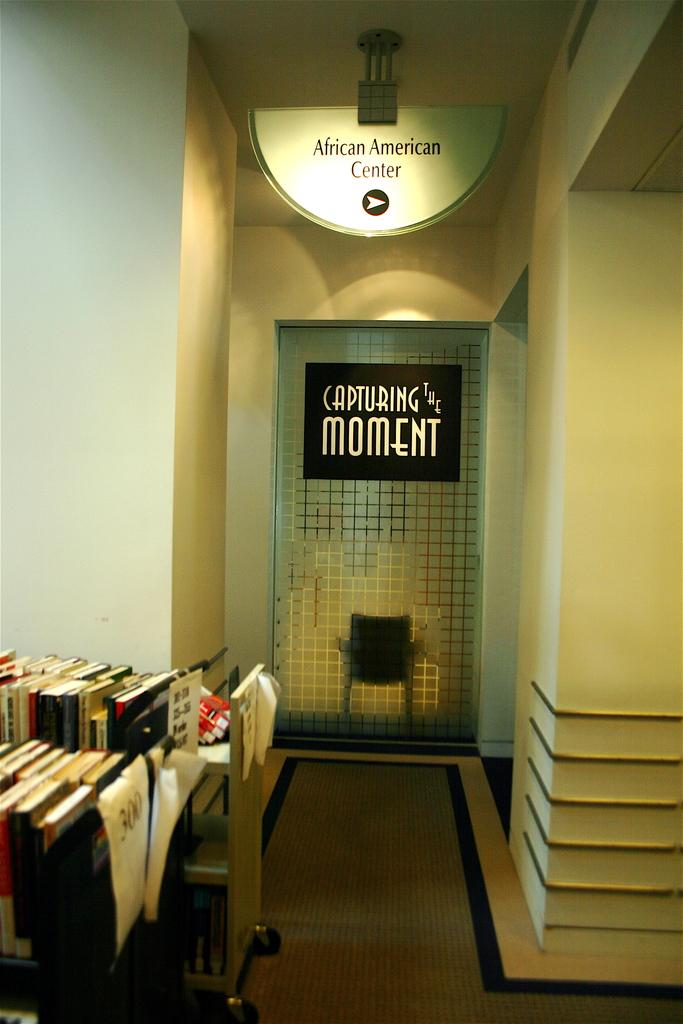What type of structure can be seen in the image? There is a wall in the image. What is hanging on the wall in the image? There is a banner in the image. What type of furniture is present in the image? There are chairs and a table in the image. What items can be seen on the table in the image? There are books on the table in the image. How much payment is required to enter the room in the image? There is no indication of payment or a room in the image; it only shows a wall, a banner, chairs, a table, and books. What type of coach is present in the image? There is no coach present in the image. 